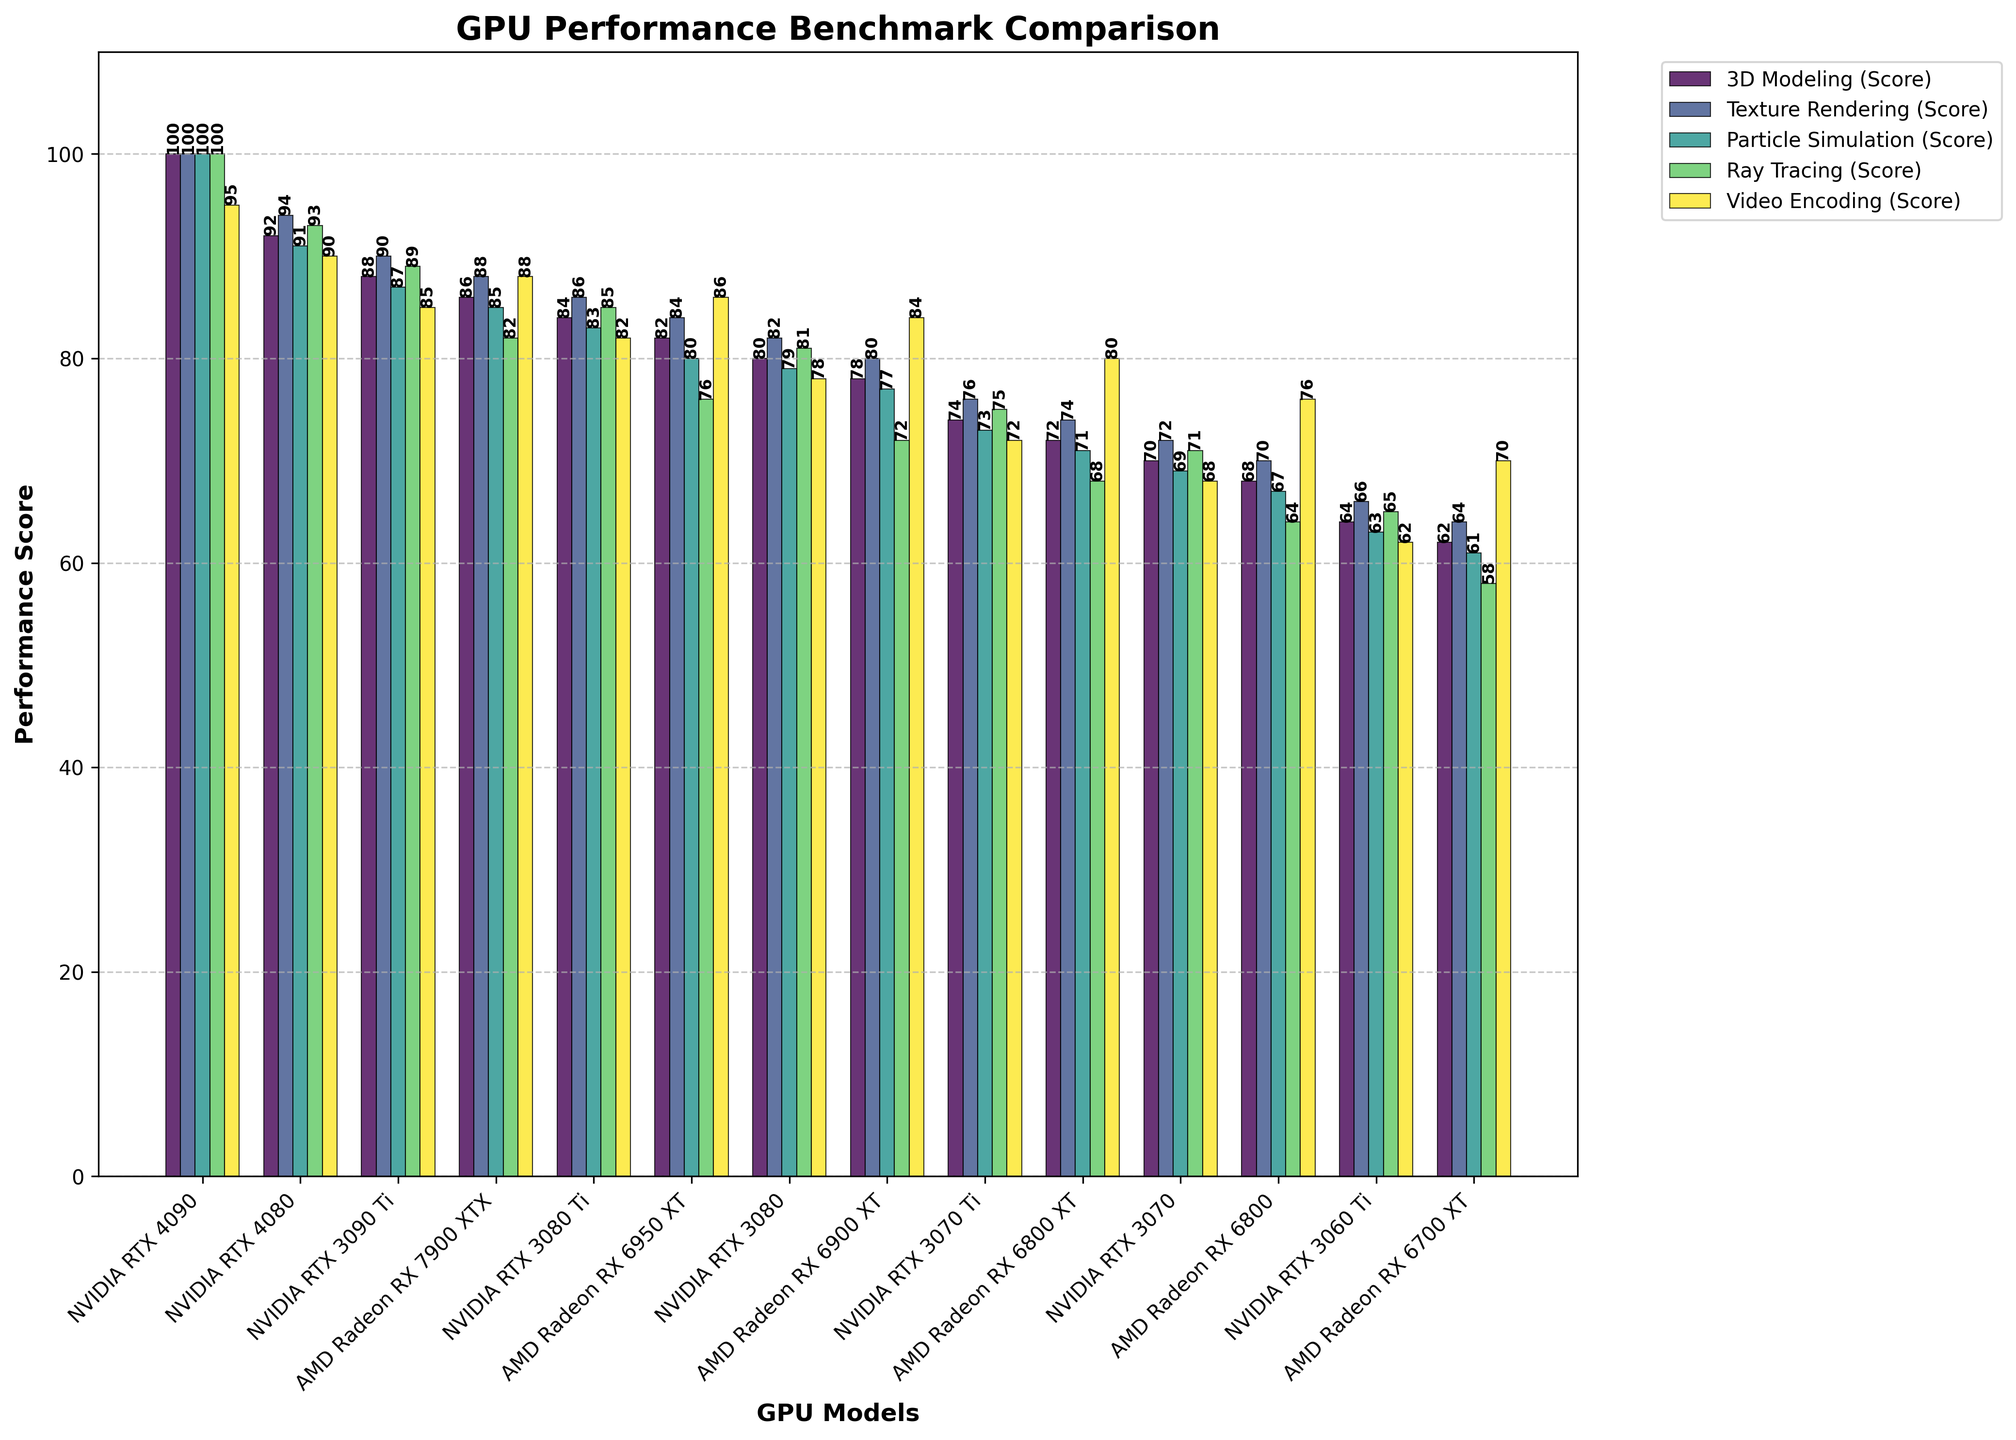Which GPU has the highest 3D Modeling score? Find the tallest bar for the category "3D Modeling (Score)" in the chart. The tallest bar corresponds to the NVIDIA RTX 4090.
Answer: NVIDIA RTX 4090 Which two GPU models have the smallest difference in Texture Rendering scores? Compare the heights of the bars for "Texture Rendering (Score)" among all GPUs and find pairs with the smallest difference in height. The NVIDIA RTX 3080 Ti and AMD Radeon RX 6950 XT have scores of 86 and 84 respectively, giving a difference of 2 points.
Answer: NVIDIA RTX 3080 Ti and AMD Radeon RX 6950 XT What is the average Particle Simulation score of the top 3 GPUs? The top 3 GPUs are NVIDIA RTX 4090, NVIDIA RTX 4080, and NVIDIA RTX 3090 Ti with scores of 100, 91, and 87 respectively. (100 + 91 + 87) / 3 = 278 / 3 approximately equals 92.67
Answer: 92.67 Which GPU has the best average score across all tasks? Calculate the average score for each GPU across all tasks and compare. The NVIDIA RTX 4090 has the highest average score. Calculation: (100 + 100 + 100 + 100 + 95) / 5 = 495 / 5 = 99
Answer: NVIDIA RTX 4090 How does the Ray Tracing score of AMD Radeon RX 6950 XT compare to NVIDIA RTX 3080? Compare the heights of the bars for "Ray Tracing (Score)" for AMD Radeon RX 6950 XT and NVIDIA RTX 3080. AMD Radeon RX 6950 XT has a score of 76, while NVIDIA RTX 3080 has a score of 81. The AMD Radeon RX 6950 XT is lower by 5 points.
Answer: AMD Radeon RX 6950 XT is lower by 5 Which GPUs have Ray Tracing scores greater than 90? Identify the bars where the "Ray Tracing (Score)" exceeds 90. Only the NVIDIA RTX 4090 and NVIDIA RTX 4080 have scores greater than 90.
Answer: NVIDIA RTX 4090 and NVIDIA RTX 4080 What is the range of Video Encoding scores? Find the highest and lowest values for the category "Video Encoding (Score)" in the chart. The highest score is 95 (NVIDIA RTX 4090) and the lowest score is 62 (NVIDIA RTX 3060 Ti). Therefore, the range is 95 - 62 = 33.
Answer: 33 Which GPU has the lowest score in 3D Modeling? Look for the shortest bar in the "3D Modeling (Score)" category in the chart. AMD Radeon RX 6700 XT is the lowest with a score of 62.
Answer: AMD Radeon RX 6700 XT How much higher is the Video Encoding score of NVIDIA RTX 4090 compared to NVIDIA RTX 3060 Ti? Subtract the Video Encoding score of NVIDIA RTX 3060 Ti from NVIDIA RTX 4090. The NVIDIA RTX 4090 has a score of 95 and NVIDIA RTX 3060 Ti has 62. Therefore, 95 - 62 = 33.
Answer: 33 What is the collective score of all GPUs in Texture Rendering? Sum up all the "Texture Rendering (Score)" values across all GPUs. (100 + 94 + 90 + 88 + 86 + 84 + 82 + 80 + 76 + 74 + 72 + 70 + 66 + 64) = 1126
Answer: 1126 